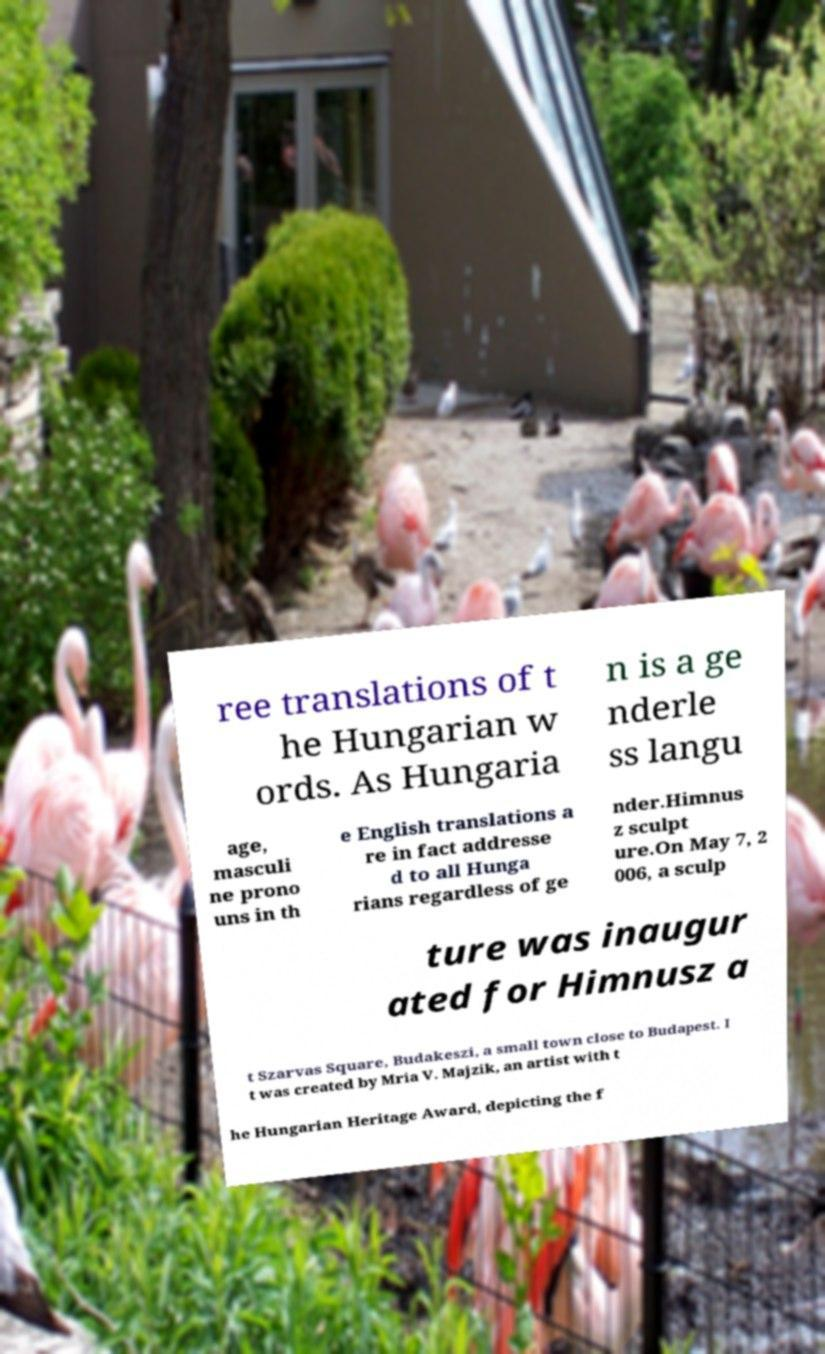Can you read and provide the text displayed in the image?This photo seems to have some interesting text. Can you extract and type it out for me? ree translations of t he Hungarian w ords. As Hungaria n is a ge nderle ss langu age, masculi ne prono uns in th e English translations a re in fact addresse d to all Hunga rians regardless of ge nder.Himnus z sculpt ure.On May 7, 2 006, a sculp ture was inaugur ated for Himnusz a t Szarvas Square, Budakeszi, a small town close to Budapest. I t was created by Mria V. Majzik, an artist with t he Hungarian Heritage Award, depicting the f 